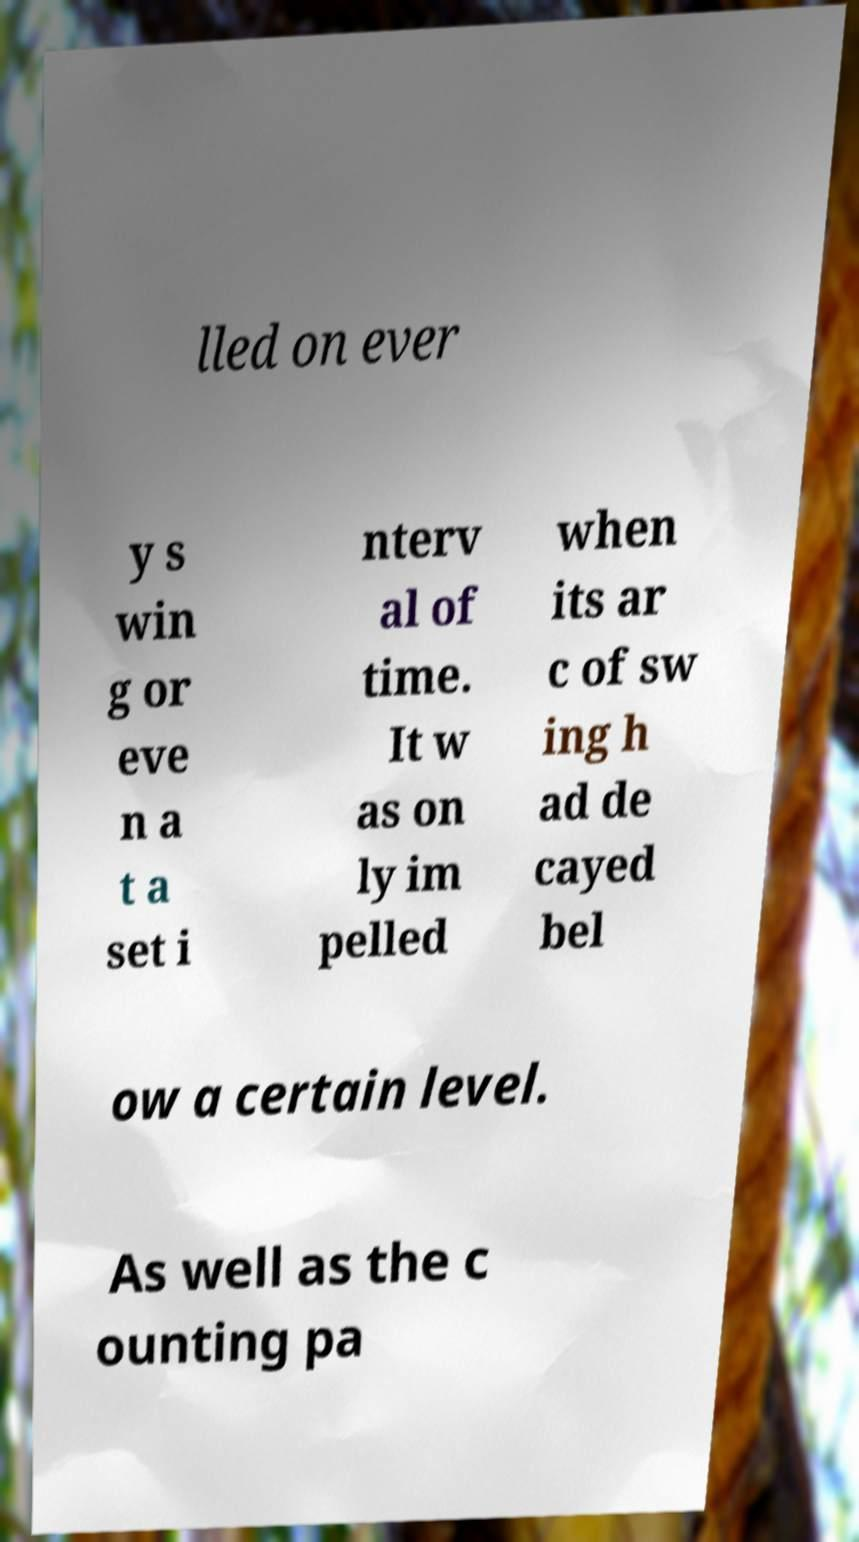There's text embedded in this image that I need extracted. Can you transcribe it verbatim? lled on ever y s win g or eve n a t a set i nterv al of time. It w as on ly im pelled when its ar c of sw ing h ad de cayed bel ow a certain level. As well as the c ounting pa 